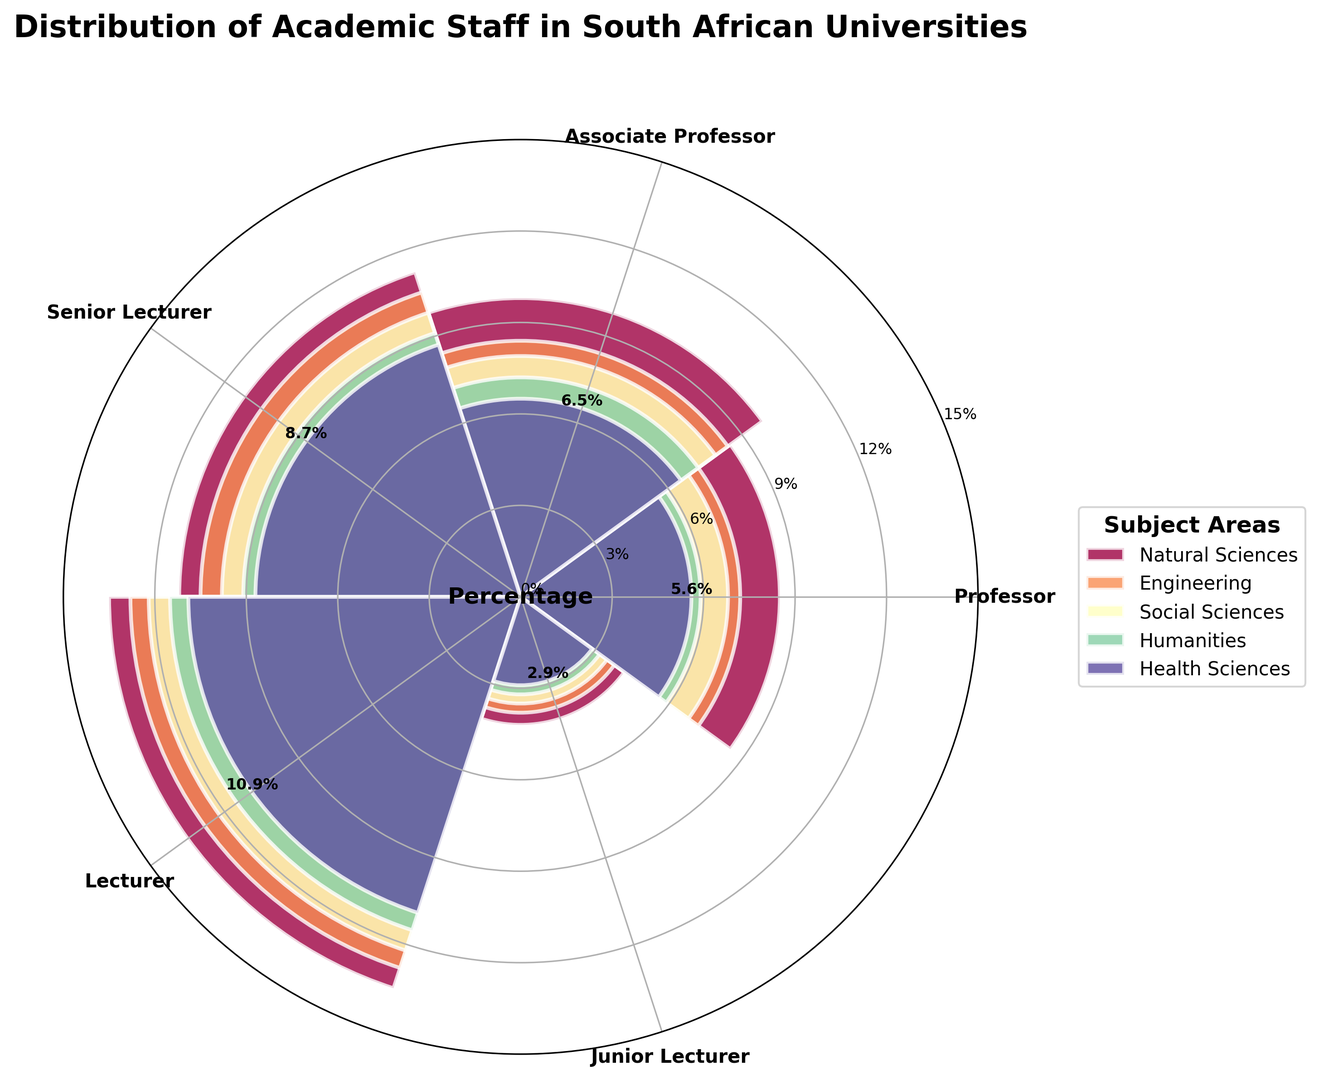What is the percentage of Professors in the Natural Sciences category? From the figure, we identify the segment representing Natural Sciences within the Professors category and read off the percentage value shown.
Answer: 8.5% Which academic rank has the highest percentage overall in any subject area? By reviewing all the bars, we see that the Lecturer rank in Natural Sciences has the highest percentage.
Answer: Lecturer in Natural Sciences Compare the percentage of Associate Professors in Engineering to Professors in the Social Sciences. Which is higher? Locate the bars for Associate Professors in Engineering and Professors in Social Sciences, then read their values. Associate Professors in Engineering have 8.4%, and Professors in Social Sciences have 6.8%.
Answer: Associate Professors in Engineering What is the total percentage of academic staff in Health Sciences across all ranks? Sum the bars for Health Sciences in all academic ranks: Professors (5.6) + Associate Professors (6.5) + Senior Lecturers (8.7) + Lecturers (10.9) + Junior Lecturers (2.9).
Answer: 34.6% Determine the average percentage of Senior Lecturers in all subject areas. Sum the percentages of Senior Lecturers in different subject areas and divide by their count: (11.2 + 10.5 + 9.8 + 9.1 + 8.7) / 5.
Answer: 9.86% What color represents the Social Sciences category? Refer to the legend of the figure which maps subject areas to colors.
Answer: It varies with the specific implementation but depends on the color scheme used (assuming a default mapping) Among the Lecturer category, which subject area has the lowest percentage and what is it? Identify the bars for the Lecturer category, and compare the percentages. Humanities has 11.5%, which is the lowest in this category.
Answer: Humanities with 11.5% Which has a greater percentage: Junior Lecturers in Natural Sciences or Senior Lecturers in Humanities? Compare the height and labeled percentage of Junior Lecturers in Natural Sciences (4.2%) and Senior Lecturers in Humanities (9.1%).
Answer: Senior Lecturers in Humanities Compare the total percentage of Professors and Associate Professors in Humanities. Sum the values for Professors and Associate Professors in Humanities respectively: Professors (5.9) + Associate Professors (7.2).
Answer: 13.1% 